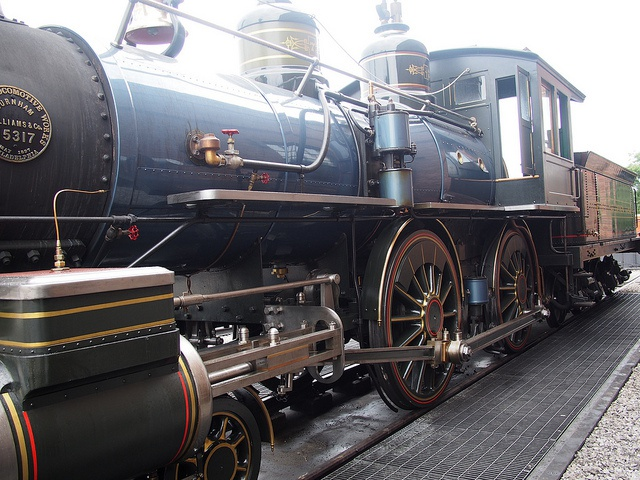Describe the objects in this image and their specific colors. I can see a train in black, white, gray, and darkgray tones in this image. 